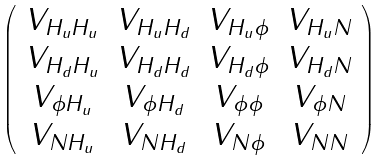<formula> <loc_0><loc_0><loc_500><loc_500>\left ( \begin{array} { c c c c } V _ { H _ { u } H _ { u } } & V _ { H _ { u } H _ { d } } & V _ { H _ { u } \phi } & V _ { H _ { u } N } \\ V _ { H _ { d } H _ { u } } & V _ { H _ { d } H _ { d } } & V _ { H _ { d } \phi } & V _ { H _ { d } N } \\ V _ { \phi H _ { u } } & V _ { \phi H _ { d } } & V _ { \phi \phi } & V _ { \phi N } \\ V _ { N H _ { u } } & V _ { N H _ { d } } & V _ { N \phi } & V _ { N N } \end{array} \right )</formula> 